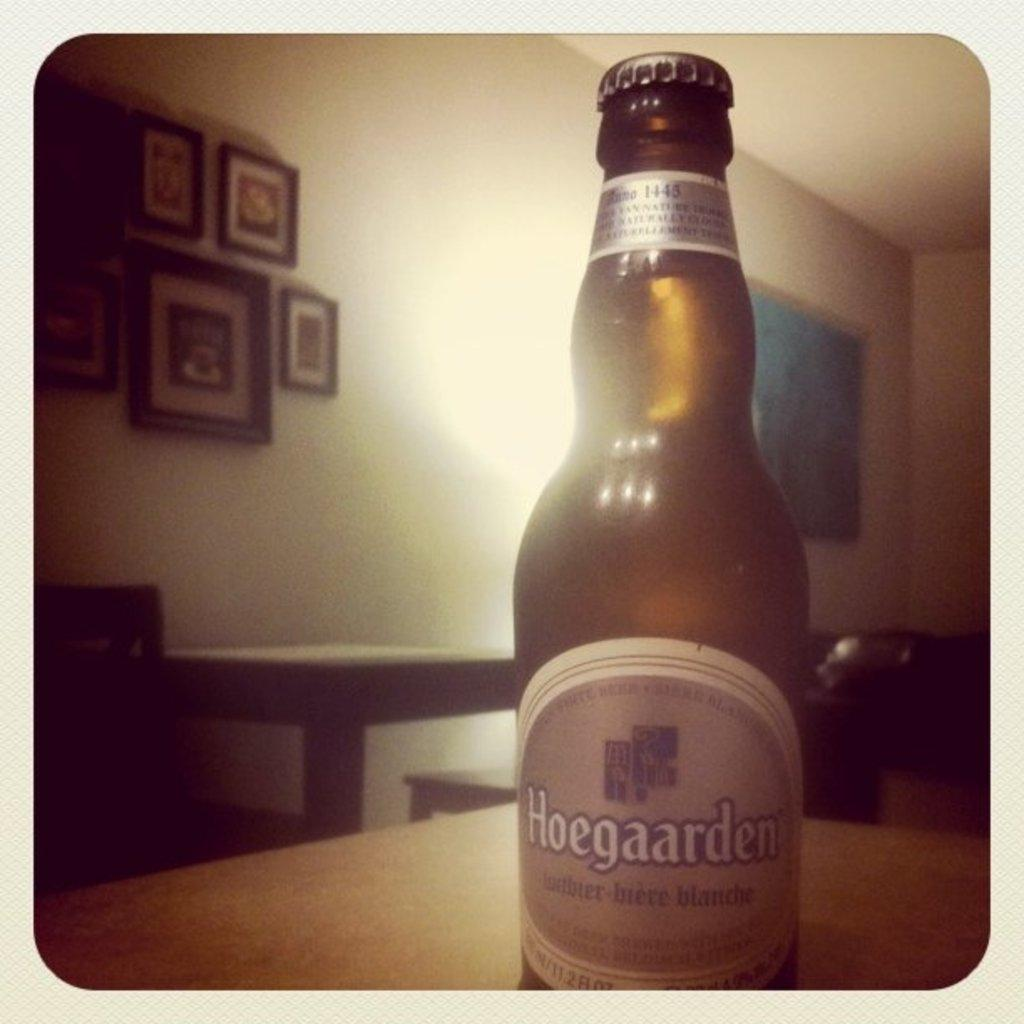<image>
Create a compact narrative representing the image presented. A bottle of beer reading Hoegaarden sits on a table. 